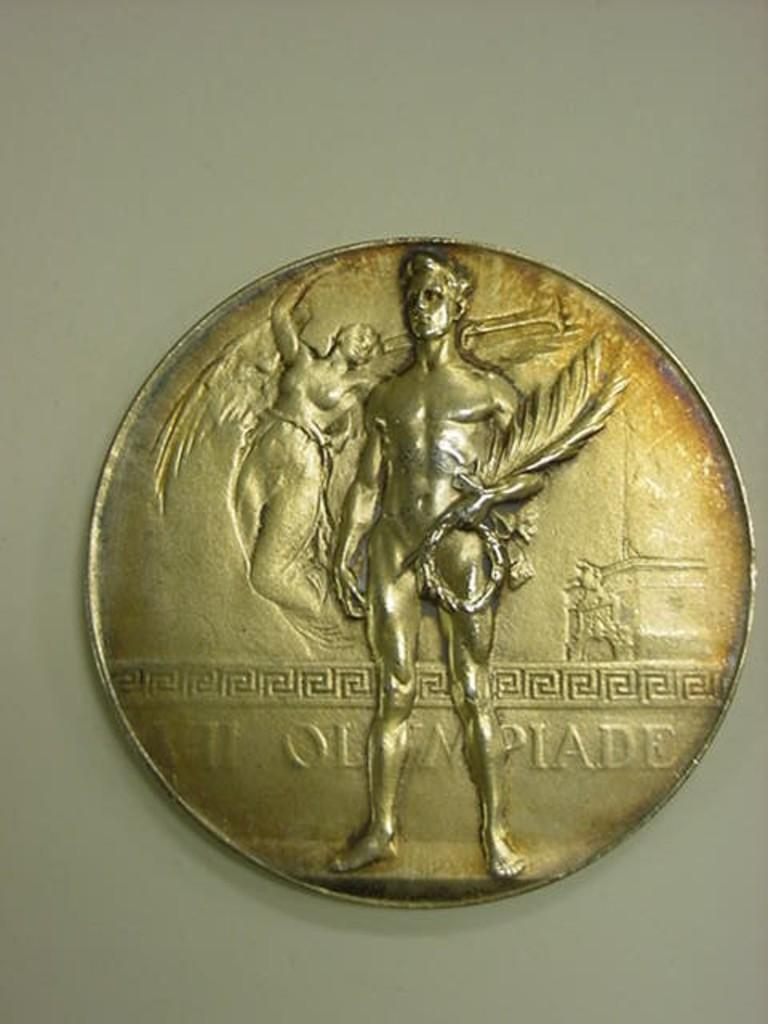<image>
Present a compact description of the photo's key features. A gold coin with the work Olympiade written on it 